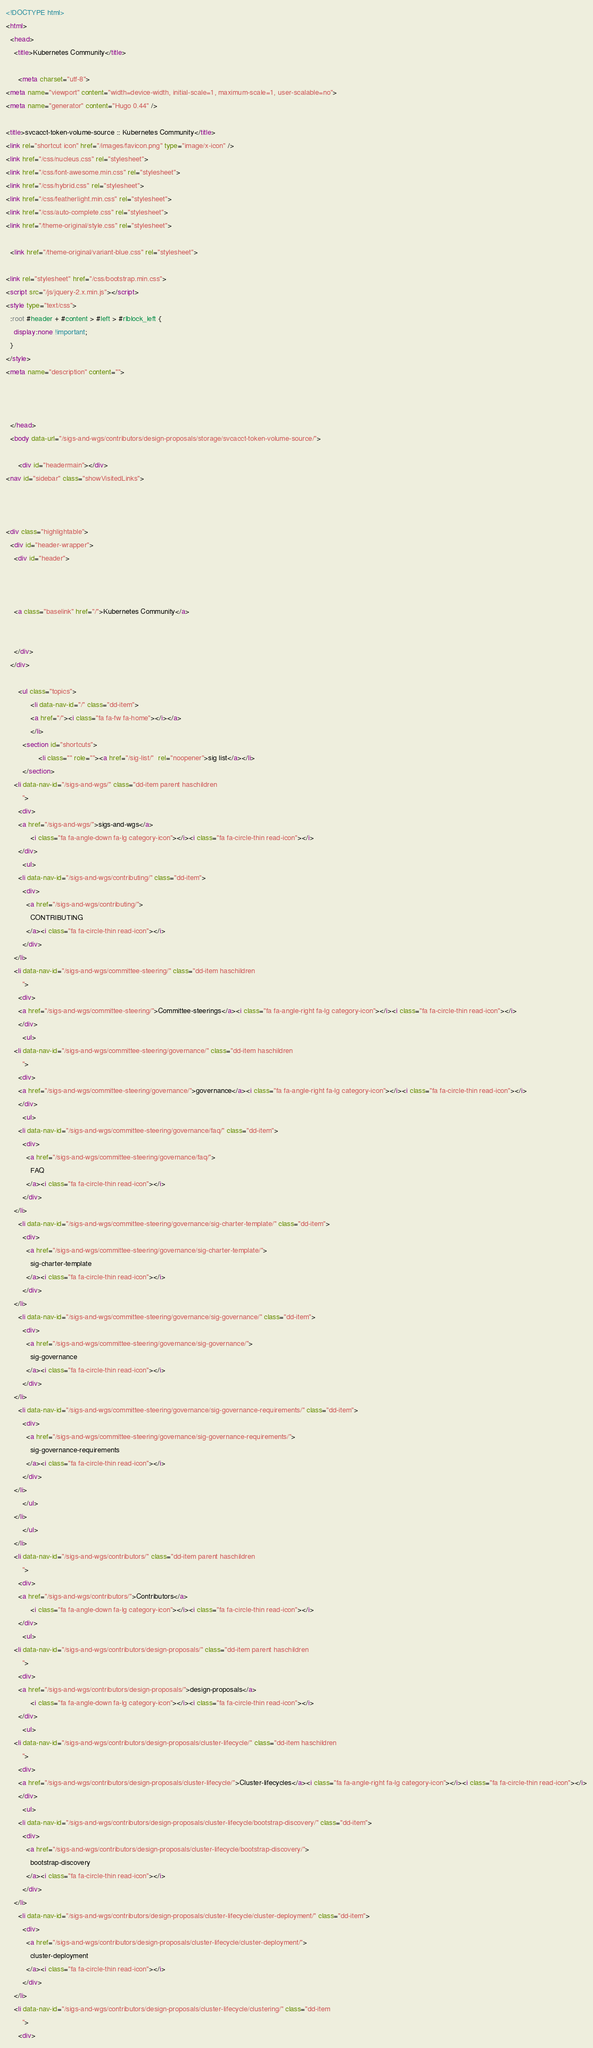Convert code to text. <code><loc_0><loc_0><loc_500><loc_500><_HTML_><!DOCTYPE html>
<html>
  <head>
    <title>Kubernetes Community</title>
    
      <meta charset="utf-8">
<meta name="viewport" content="width=device-width, initial-scale=1, maximum-scale=1, user-scalable=no">
<meta name="generator" content="Hugo 0.44" />

<title>svcacct-token-volume-source :: Kubernetes Community</title>
<link rel="shortcut icon" href="/images/favicon.png" type="image/x-icon" />
<link href="/css/nucleus.css" rel="stylesheet">
<link href="/css/font-awesome.min.css" rel="stylesheet">
<link href="/css/hybrid.css" rel="stylesheet">
<link href="/css/featherlight.min.css" rel="stylesheet">
<link href="/css/auto-complete.css" rel="stylesheet">
<link href="/theme-original/style.css" rel="stylesheet">

  <link href="/theme-original/variant-blue.css" rel="stylesheet">

<link rel="stylesheet" href="/css/bootstrap.min.css">
<script src="/js/jquery-2.x.min.js"></script>
<style type="text/css">
  :root #header + #content > #left > #rlblock_left {
    display:none !important;
  }
</style>
<meta name="description" content="">


    
  </head>
  <body data-url="/sigs-and-wgs/contributors/design-proposals/storage/svcacct-token-volume-source/">
    
      <div id="headermain"></div>
<nav id="sidebar" class="showVisitedLinks">



<div class="highlightable">
  <div id="header-wrapper">
    <div id="header">
      
	
  
    <a class="baselink" href="/">Kubernetes Community</a>
  

    </div>
  </div>

      <ul class="topics">
            <li data-nav-id="/" class="dd-item">
            <a href="/"><i class="fa fa-fw fa-home"></i></a>
            </li>
        <section id="shortcuts">
                <li class="" role=""><a href="/sig-list/"  rel="noopener">sig list</a></li>
        </section>
    <li data-nav-id="/sigs-and-wgs/" class="dd-item parent haschildren
        ">
      <div>
      <a href="/sigs-and-wgs/">sigs-and-wgs</a>
            <i class="fa fa-angle-down fa-lg category-icon"></i><i class="fa fa-circle-thin read-icon"></i>
      </div>
        <ul>
      <li data-nav-id="/sigs-and-wgs/contributing/" class="dd-item">
        <div>
          <a href="/sigs-and-wgs/contributing/">
            CONTRIBUTING
          </a><i class="fa fa-circle-thin read-icon"></i>
        </div>
    </li>
    <li data-nav-id="/sigs-and-wgs/committee-steering/" class="dd-item haschildren
        ">
      <div>
      <a href="/sigs-and-wgs/committee-steering/">Committee-steerings</a><i class="fa fa-angle-right fa-lg category-icon"></i><i class="fa fa-circle-thin read-icon"></i>
      </div>
        <ul>
    <li data-nav-id="/sigs-and-wgs/committee-steering/governance/" class="dd-item haschildren
        ">
      <div>
      <a href="/sigs-and-wgs/committee-steering/governance/">governance</a><i class="fa fa-angle-right fa-lg category-icon"></i><i class="fa fa-circle-thin read-icon"></i>
      </div>
        <ul>
      <li data-nav-id="/sigs-and-wgs/committee-steering/governance/faq/" class="dd-item">
        <div>
          <a href="/sigs-and-wgs/committee-steering/governance/faq/">
            FAQ
          </a><i class="fa fa-circle-thin read-icon"></i>
        </div>
    </li>
      <li data-nav-id="/sigs-and-wgs/committee-steering/governance/sig-charter-template/" class="dd-item">
        <div>
          <a href="/sigs-and-wgs/committee-steering/governance/sig-charter-template/">
            sig-charter-template
          </a><i class="fa fa-circle-thin read-icon"></i>
        </div>
    </li>
      <li data-nav-id="/sigs-and-wgs/committee-steering/governance/sig-governance/" class="dd-item">
        <div>
          <a href="/sigs-and-wgs/committee-steering/governance/sig-governance/">
            sig-governance
          </a><i class="fa fa-circle-thin read-icon"></i>
        </div>
    </li>
      <li data-nav-id="/sigs-and-wgs/committee-steering/governance/sig-governance-requirements/" class="dd-item">
        <div>
          <a href="/sigs-and-wgs/committee-steering/governance/sig-governance-requirements/">
            sig-governance-requirements
          </a><i class="fa fa-circle-thin read-icon"></i>
        </div>
    </li>
        </ul>
    </li>
        </ul>
    </li>
    <li data-nav-id="/sigs-and-wgs/contributors/" class="dd-item parent haschildren
        ">
      <div>
      <a href="/sigs-and-wgs/contributors/">Contributors</a>
            <i class="fa fa-angle-down fa-lg category-icon"></i><i class="fa fa-circle-thin read-icon"></i>
      </div>
        <ul>
    <li data-nav-id="/sigs-and-wgs/contributors/design-proposals/" class="dd-item parent haschildren
        ">
      <div>
      <a href="/sigs-and-wgs/contributors/design-proposals/">design-proposals</a>
            <i class="fa fa-angle-down fa-lg category-icon"></i><i class="fa fa-circle-thin read-icon"></i>
      </div>
        <ul>
    <li data-nav-id="/sigs-and-wgs/contributors/design-proposals/cluster-lifecycle/" class="dd-item haschildren
        ">
      <div>
      <a href="/sigs-and-wgs/contributors/design-proposals/cluster-lifecycle/">Cluster-lifecycles</a><i class="fa fa-angle-right fa-lg category-icon"></i><i class="fa fa-circle-thin read-icon"></i>
      </div>
        <ul>
      <li data-nav-id="/sigs-and-wgs/contributors/design-proposals/cluster-lifecycle/bootstrap-discovery/" class="dd-item">
        <div>
          <a href="/sigs-and-wgs/contributors/design-proposals/cluster-lifecycle/bootstrap-discovery/">
            bootstrap-discovery
          </a><i class="fa fa-circle-thin read-icon"></i>
        </div>
    </li>
      <li data-nav-id="/sigs-and-wgs/contributors/design-proposals/cluster-lifecycle/cluster-deployment/" class="dd-item">
        <div>
          <a href="/sigs-and-wgs/contributors/design-proposals/cluster-lifecycle/cluster-deployment/">
            cluster-deployment
          </a><i class="fa fa-circle-thin read-icon"></i>
        </div>
    </li>
    <li data-nav-id="/sigs-and-wgs/contributors/design-proposals/cluster-lifecycle/clustering/" class="dd-item
        ">
      <div></code> 